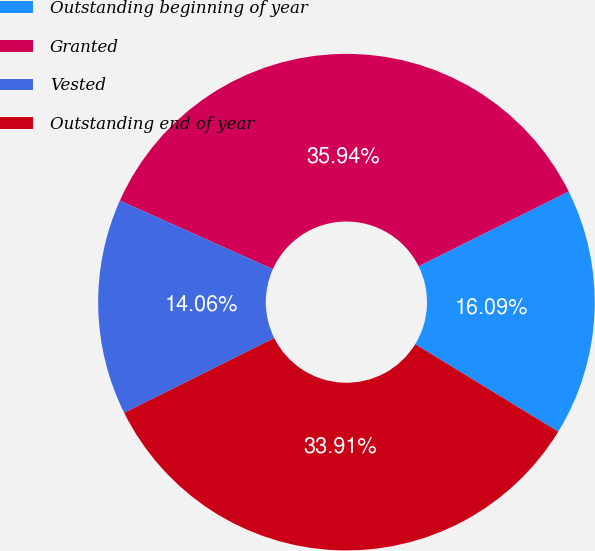Convert chart to OTSL. <chart><loc_0><loc_0><loc_500><loc_500><pie_chart><fcel>Outstanding beginning of year<fcel>Granted<fcel>Vested<fcel>Outstanding end of year<nl><fcel>16.09%<fcel>35.94%<fcel>14.06%<fcel>33.91%<nl></chart> 